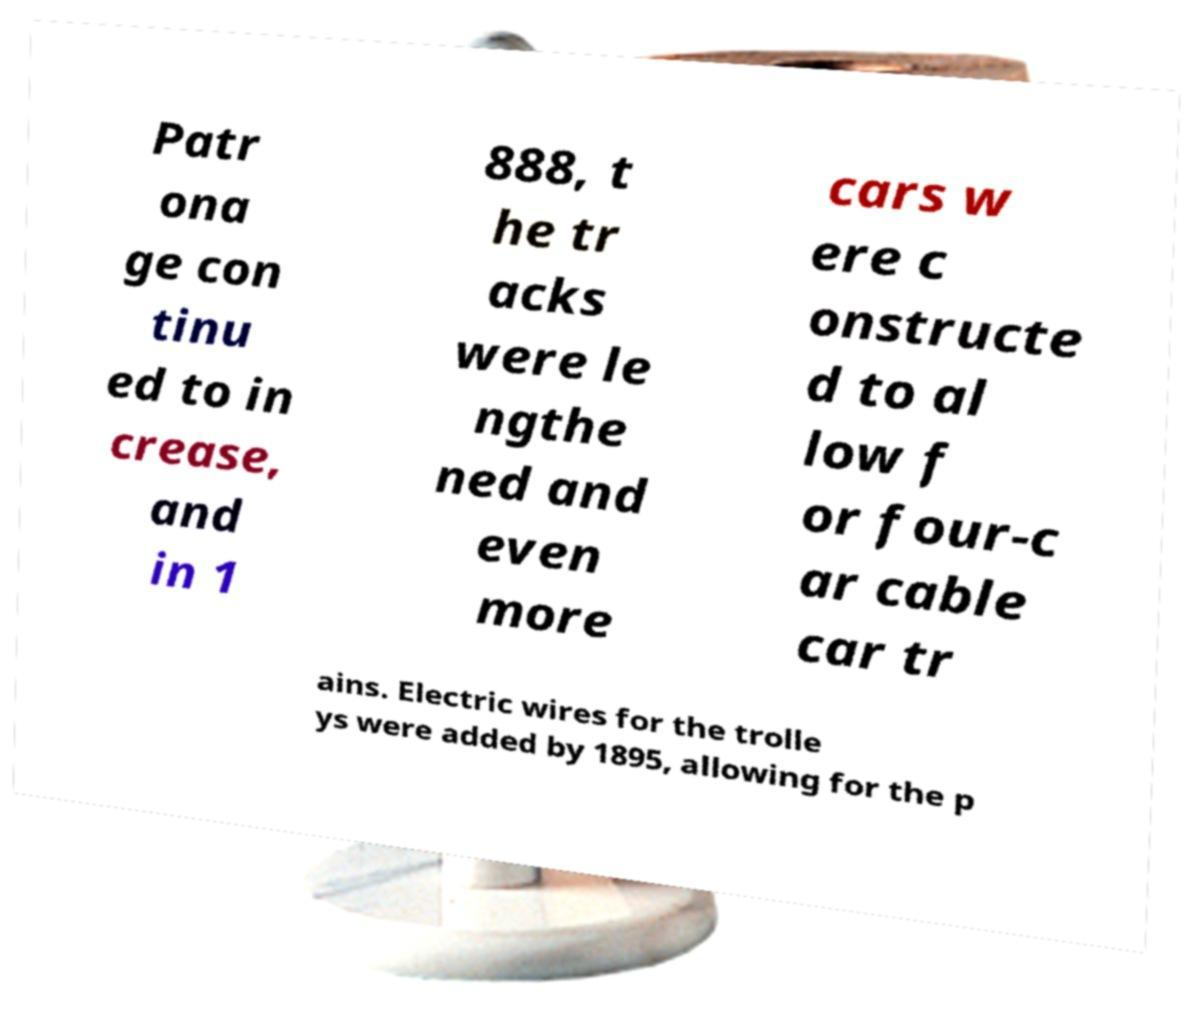Can you read and provide the text displayed in the image?This photo seems to have some interesting text. Can you extract and type it out for me? Patr ona ge con tinu ed to in crease, and in 1 888, t he tr acks were le ngthe ned and even more cars w ere c onstructe d to al low f or four-c ar cable car tr ains. Electric wires for the trolle ys were added by 1895, allowing for the p 